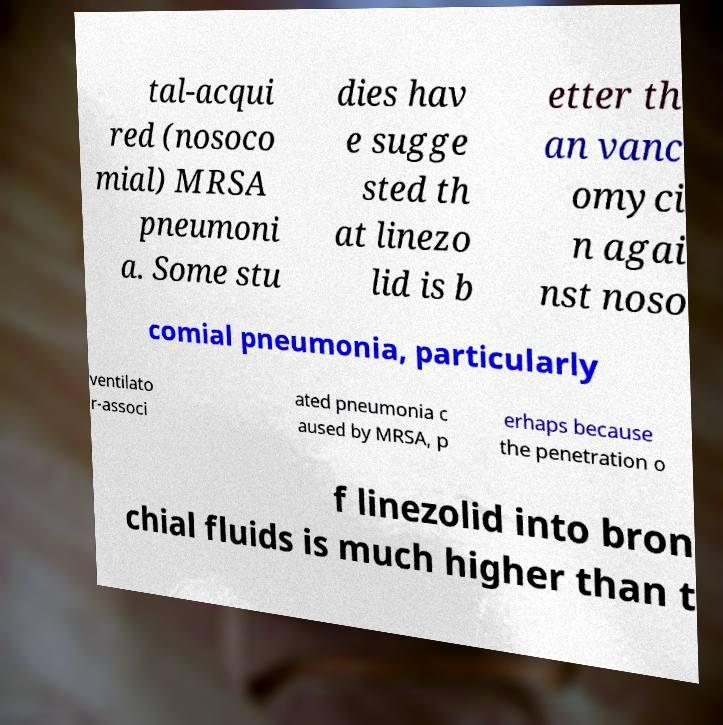What messages or text are displayed in this image? I need them in a readable, typed format. tal-acqui red (nosoco mial) MRSA pneumoni a. Some stu dies hav e sugge sted th at linezo lid is b etter th an vanc omyci n agai nst noso comial pneumonia, particularly ventilato r-associ ated pneumonia c aused by MRSA, p erhaps because the penetration o f linezolid into bron chial fluids is much higher than t 